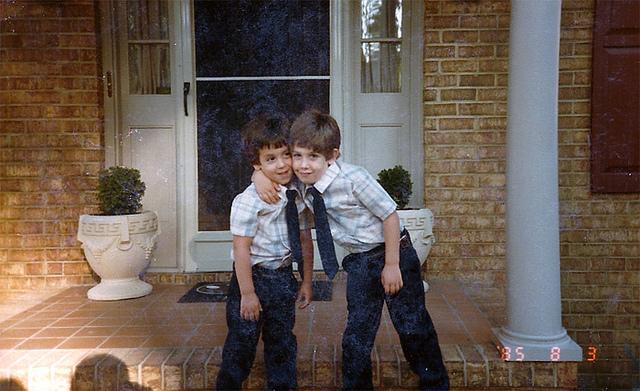What year was this picture taken?
Answer briefly. 1985. Do they have matching clothes?
Give a very brief answer. Yes. Are these boys twins?
Concise answer only. No. 